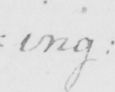What is written in this line of handwriting? =ing : 